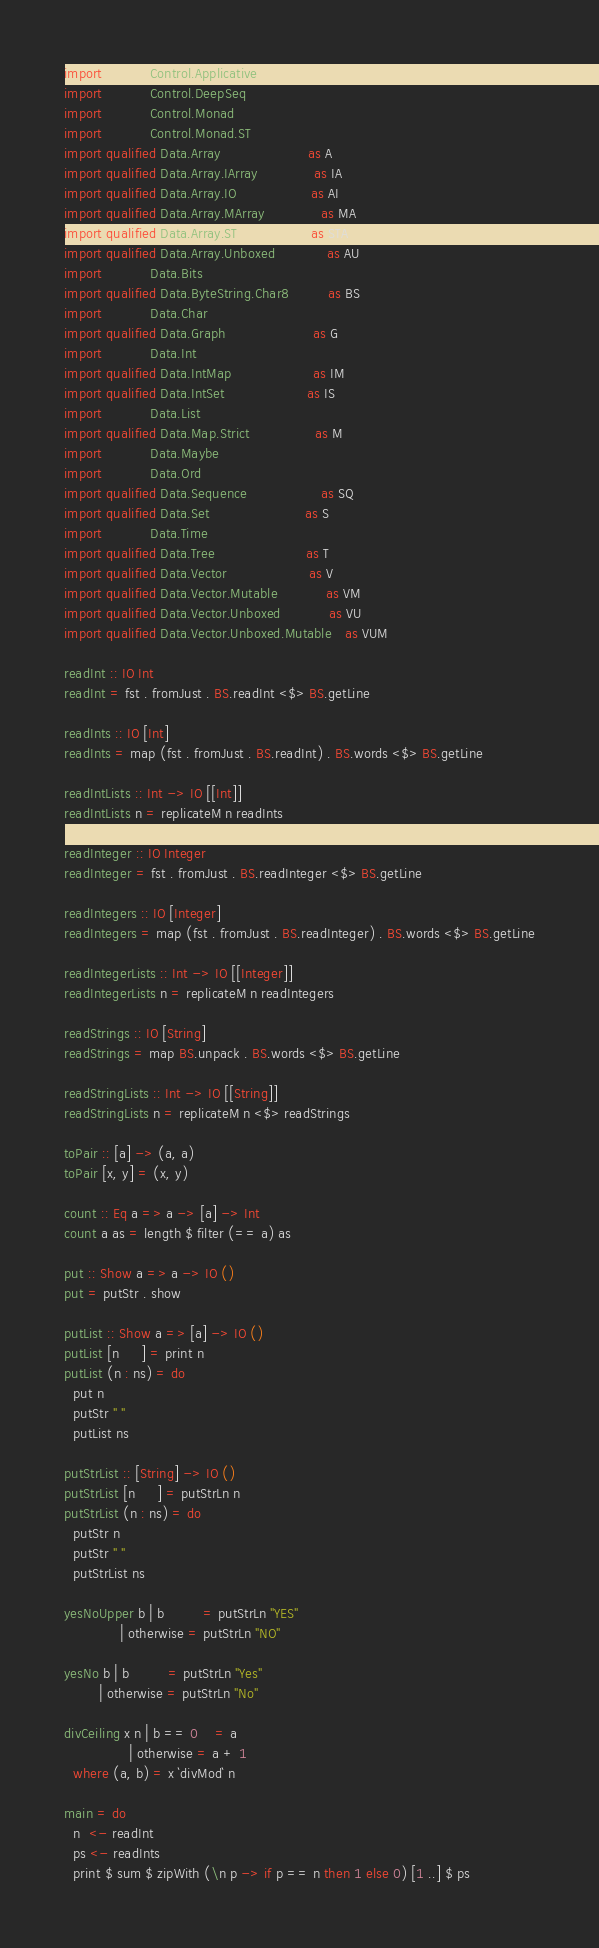<code> <loc_0><loc_0><loc_500><loc_500><_Haskell_>import           Control.Applicative
import           Control.DeepSeq
import           Control.Monad
import           Control.Monad.ST
import qualified Data.Array                    as A
import qualified Data.Array.IArray             as IA
import qualified Data.Array.IO                 as AI
import qualified Data.Array.MArray             as MA
import qualified Data.Array.ST                 as STA
import qualified Data.Array.Unboxed            as AU
import           Data.Bits
import qualified Data.ByteString.Char8         as BS
import           Data.Char
import qualified Data.Graph                    as G
import           Data.Int
import qualified Data.IntMap                   as IM
import qualified Data.IntSet                   as IS
import           Data.List
import qualified Data.Map.Strict               as M
import           Data.Maybe
import           Data.Ord
import qualified Data.Sequence                 as SQ
import qualified Data.Set                      as S
import           Data.Time
import qualified Data.Tree                     as T
import qualified Data.Vector                   as V
import qualified Data.Vector.Mutable           as VM
import qualified Data.Vector.Unboxed           as VU
import qualified Data.Vector.Unboxed.Mutable   as VUM

readInt :: IO Int
readInt = fst . fromJust . BS.readInt <$> BS.getLine

readInts :: IO [Int]
readInts = map (fst . fromJust . BS.readInt) . BS.words <$> BS.getLine

readIntLists :: Int -> IO [[Int]]
readIntLists n = replicateM n readInts

readInteger :: IO Integer
readInteger = fst . fromJust . BS.readInteger <$> BS.getLine

readIntegers :: IO [Integer]
readIntegers = map (fst . fromJust . BS.readInteger) . BS.words <$> BS.getLine

readIntegerLists :: Int -> IO [[Integer]]
readIntegerLists n = replicateM n readIntegers

readStrings :: IO [String]
readStrings = map BS.unpack . BS.words <$> BS.getLine

readStringLists :: Int -> IO [[String]]
readStringLists n = replicateM n <$> readStrings

toPair :: [a] -> (a, a)
toPair [x, y] = (x, y)

count :: Eq a => a -> [a] -> Int
count a as = length $ filter (== a) as

put :: Show a => a -> IO ()
put = putStr . show

putList :: Show a => [a] -> IO ()
putList [n     ] = print n
putList (n : ns) = do
  put n
  putStr " "
  putList ns

putStrList :: [String] -> IO ()
putStrList [n     ] = putStrLn n
putStrList (n : ns) = do
  putStr n
  putStr " "
  putStrList ns

yesNoUpper b | b         = putStrLn "YES"
             | otherwise = putStrLn "NO"

yesNo b | b         = putStrLn "Yes"
        | otherwise = putStrLn "No"

divCeiling x n | b == 0    = a
               | otherwise = a + 1
  where (a, b) = x `divMod` n

main = do
  n  <- readInt
  ps <- readInts
  print $ sum $ zipWith (\n p -> if p == n then 1 else 0) [1 ..] $ ps
</code> 